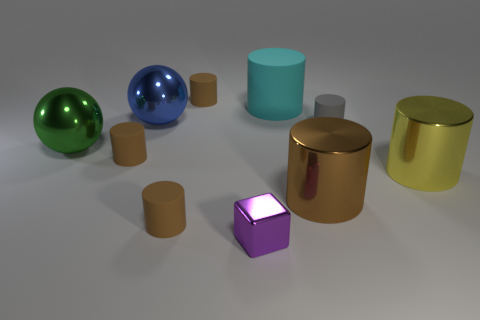Subtract all cyan cubes. How many brown cylinders are left? 4 Subtract 3 cylinders. How many cylinders are left? 4 Subtract all big cylinders. How many cylinders are left? 4 Subtract all gray cylinders. How many cylinders are left? 6 Subtract all red cylinders. Subtract all brown blocks. How many cylinders are left? 7 Subtract all blocks. How many objects are left? 9 Add 4 blue metal spheres. How many blue metal spheres exist? 5 Subtract 0 green cubes. How many objects are left? 10 Subtract all large blue metallic objects. Subtract all brown objects. How many objects are left? 5 Add 3 blue spheres. How many blue spheres are left? 4 